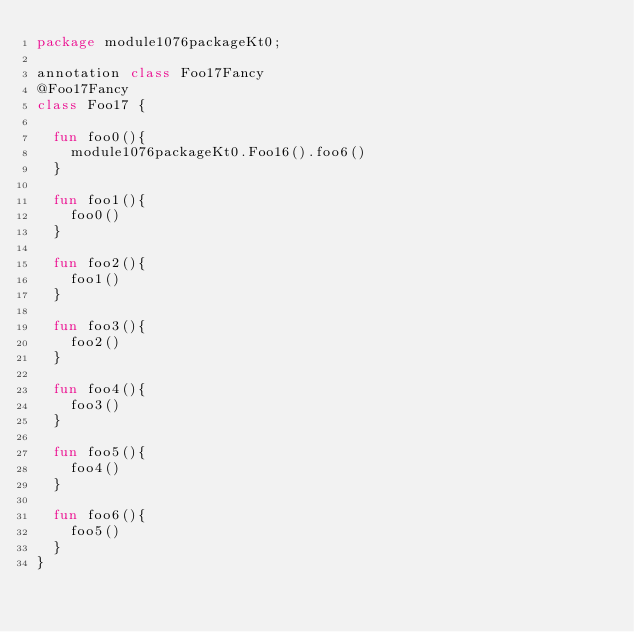<code> <loc_0><loc_0><loc_500><loc_500><_Kotlin_>package module1076packageKt0;

annotation class Foo17Fancy
@Foo17Fancy
class Foo17 {

  fun foo0(){
    module1076packageKt0.Foo16().foo6()
  }

  fun foo1(){
    foo0()
  }

  fun foo2(){
    foo1()
  }

  fun foo3(){
    foo2()
  }

  fun foo4(){
    foo3()
  }

  fun foo5(){
    foo4()
  }

  fun foo6(){
    foo5()
  }
}</code> 